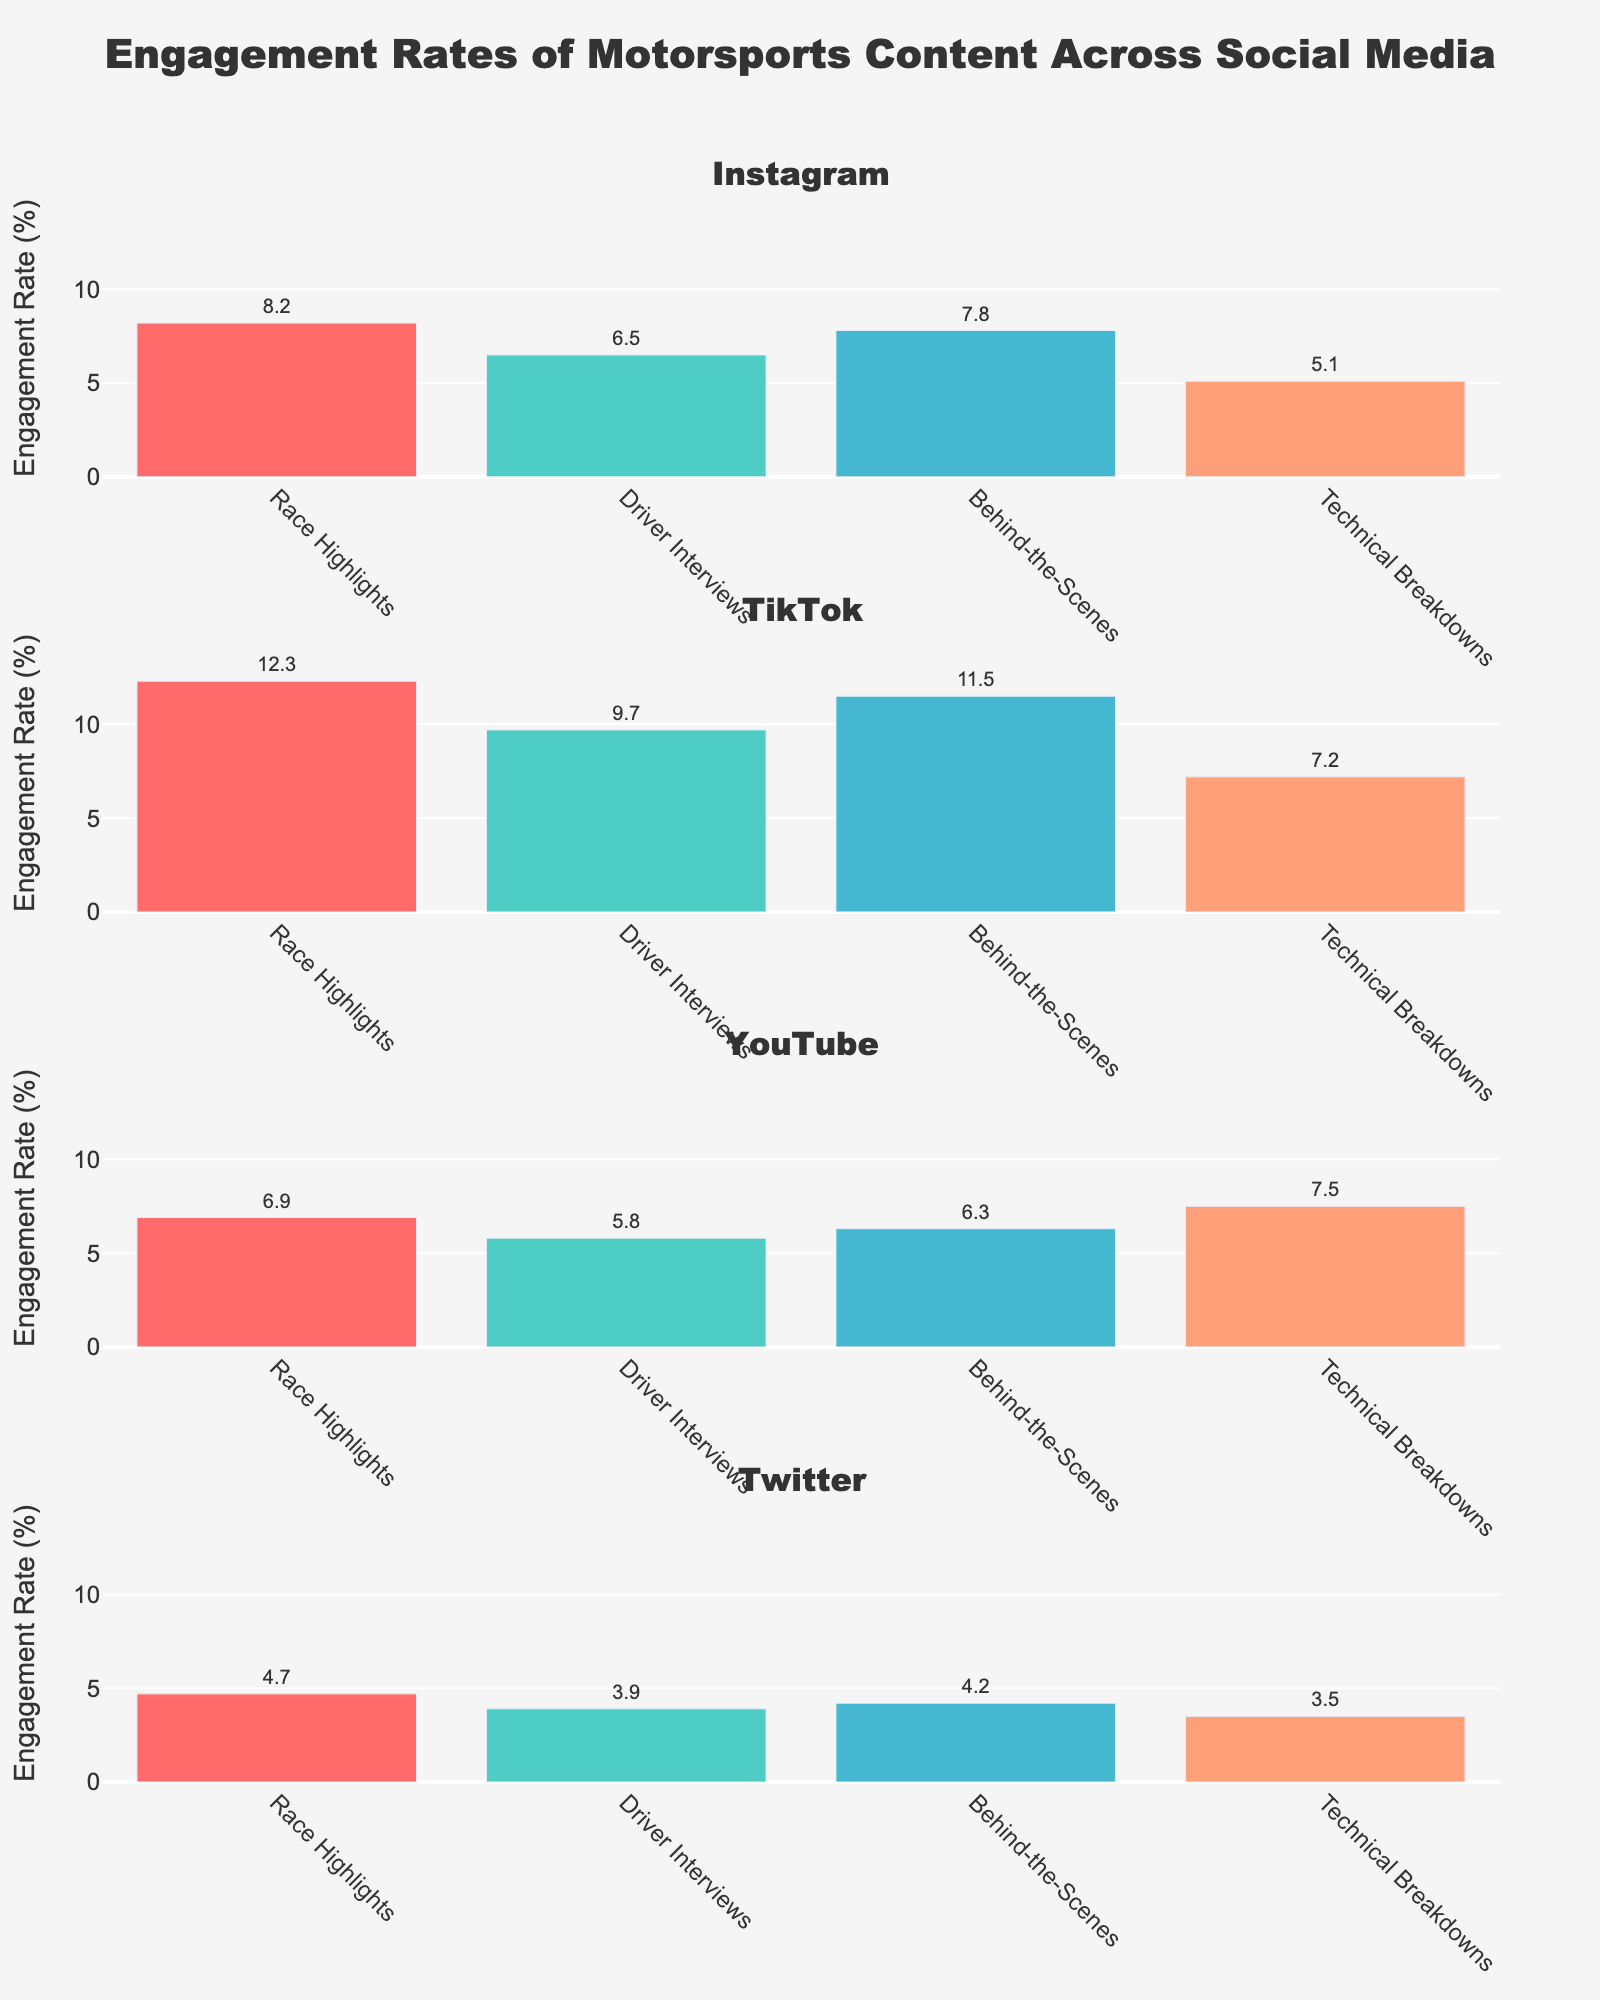what is the title of the plot? The title is usually displayed prominently at the top of the figure. Here, the title is "Comparative Analysis of Automotive Sales Models."
Answer: "Comparative Analysis of Automotive Sales Models." What's the color of the line representing Tesla Direct Sales? To answer, look at the visual appearance of the line labeled "Tesla Direct Sales." The line is colored red.
Answer: Red How many years does the data span? The x-axis provides the years covered in the data. From 2018 to 2023, there are six years in total.
Answer: 6 years Did Rivian Direct Sales have any sales before 2021? Observe the subplot specifically for "Rivian Direct Sales." The plot indicates that Rivian has no sales data before 2021.
Answer: No In which year did Tesla have the highest number of direct sales? To find the highest point on the Tesla Direct Sales line, look for the year where this line peaks. This occurs in 2023.
Answer: 2023 Compare the sales of Traditional Dealerships and Tesla Direct Sales in 2020. Which one is higher? Check the values on the lines for 2020; Traditional Dealerships significantly outnumber Tesla Direct Sales. Traditional Dealerships are at 14,465,600, while Tesla Direct Sales are at 499,550.
Answer: Traditional Dealerships What is the difference in the number of vehicles sold between Traditional Dealerships and Lucid Direct Sales in 2023? Look at the y-values for 2023. Traditional Dealerships are at 14,950,000 and Lucid Direct Sales are at 12,000. Subtracting the Lucid values from Traditional Dealerships gives the difference. 14,950,000 - 12,000 = 14,938,000.
Answer: 14,938,000 Which direct sales model shows rapid growth after 2018 compared to the others? By comparing the upward trend lines in the second subplot, it's evident that "Tesla Direct Sales" rapidly increases after 2018 compared to Rivian and Lucid.
Answer: Tesla Direct Sales How does the y-axis scaling differ between the two subplots? The first subplot uses a logarithmic scale for the y-axis, while the second subplot uses a linear scale.
Answer: The first subplot uses logarithmic, the second uses linear In which year did Lucid start reporting direct sales, and how many units did they sell that year? By looking at the second subplot for the Lucid Direct Sales line, Lucid starts reporting in 2021, with 520 units sold in that year.
Answer: 2021, 520 units 